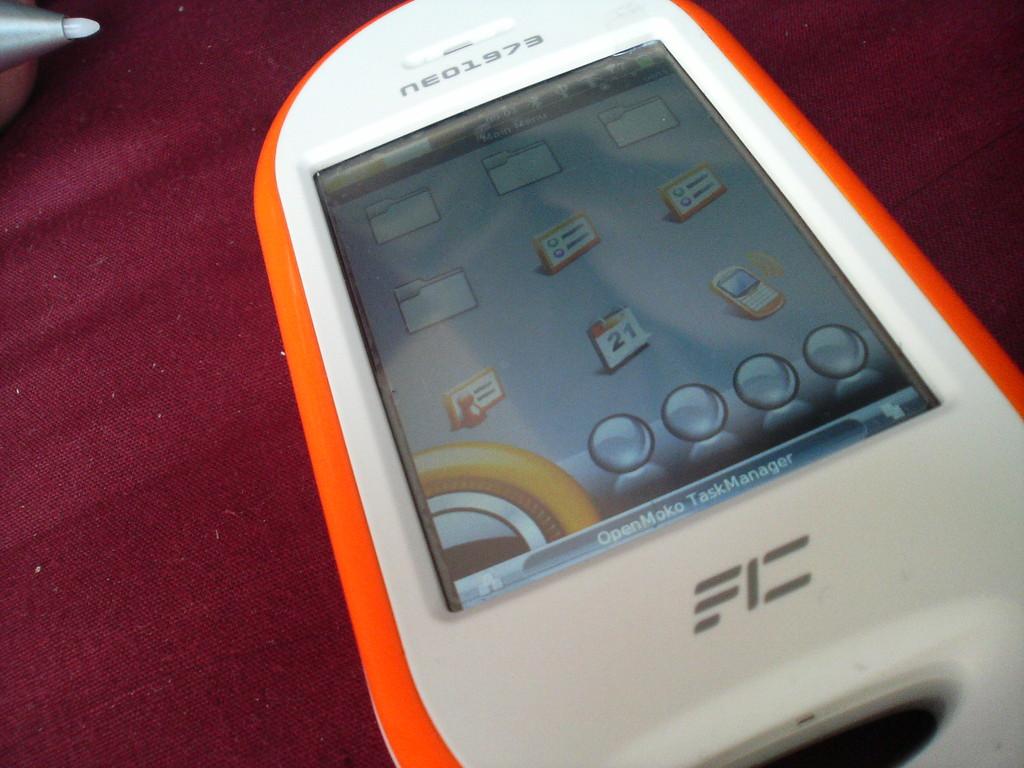What is the brand of this device?
Offer a very short reply. Neo1973. What are the words displayed at the bottom of the screen?
Offer a very short reply. Openmoko taskmanager. 